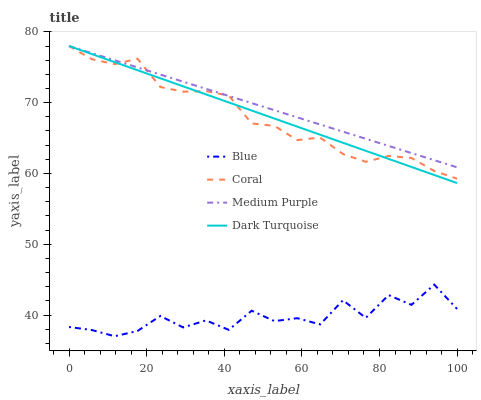Does Blue have the minimum area under the curve?
Answer yes or no. Yes. Does Medium Purple have the maximum area under the curve?
Answer yes or no. Yes. Does Coral have the minimum area under the curve?
Answer yes or no. No. Does Coral have the maximum area under the curve?
Answer yes or no. No. Is Dark Turquoise the smoothest?
Answer yes or no. Yes. Is Blue the roughest?
Answer yes or no. Yes. Is Medium Purple the smoothest?
Answer yes or no. No. Is Medium Purple the roughest?
Answer yes or no. No. Does Blue have the lowest value?
Answer yes or no. Yes. Does Coral have the lowest value?
Answer yes or no. No. Does Dark Turquoise have the highest value?
Answer yes or no. Yes. Is Blue less than Dark Turquoise?
Answer yes or no. Yes. Is Coral greater than Blue?
Answer yes or no. Yes. Does Dark Turquoise intersect Medium Purple?
Answer yes or no. Yes. Is Dark Turquoise less than Medium Purple?
Answer yes or no. No. Is Dark Turquoise greater than Medium Purple?
Answer yes or no. No. Does Blue intersect Dark Turquoise?
Answer yes or no. No. 